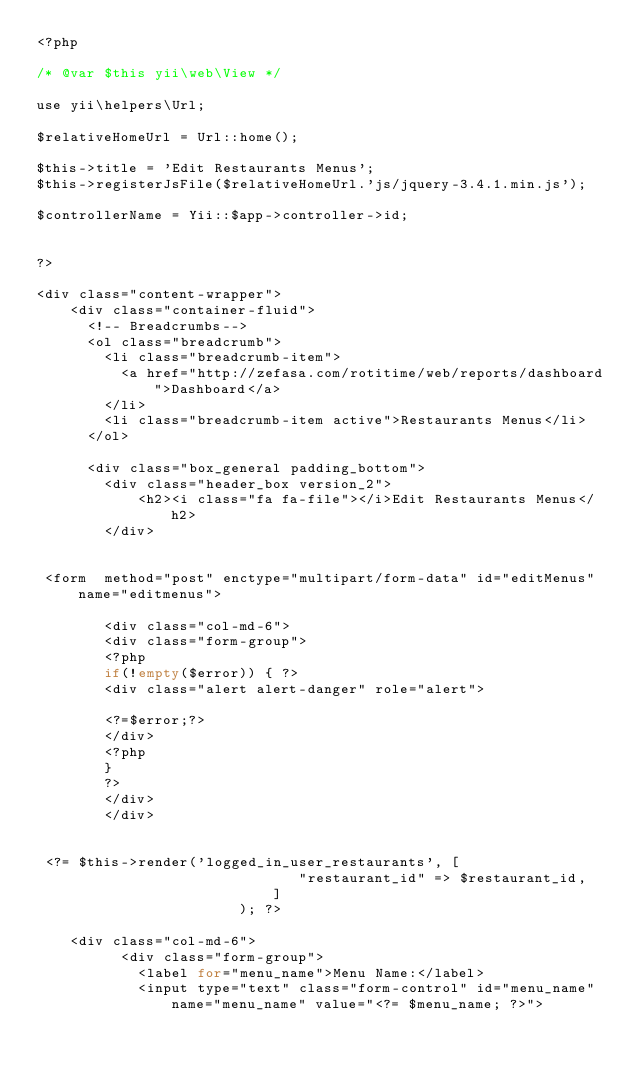Convert code to text. <code><loc_0><loc_0><loc_500><loc_500><_PHP_><?php

/* @var $this yii\web\View */

use yii\helpers\Url;

$relativeHomeUrl = Url::home();

$this->title = 'Edit Restaurants Menus';
$this->registerJsFile($relativeHomeUrl.'js/jquery-3.4.1.min.js');

$controllerName = Yii::$app->controller->id;


?>

<div class="content-wrapper">
    <div class="container-fluid">
      <!-- Breadcrumbs-->
      <ol class="breadcrumb">
        <li class="breadcrumb-item">
          <a href="http://zefasa.com/rotitime/web/reports/dashboard">Dashboard</a>
        </li>
        <li class="breadcrumb-item active">Restaurants Menus</li>
      </ol>

      <div class="box_general padding_bottom">
        <div class="header_box version_2">
            <h2><i class="fa fa-file"></i>Edit Restaurants Menus</h2>
        </div>
		
		
 <form  method="post" enctype="multipart/form-data" id="editMenus" name="editmenus">
 
        <div class="col-md-6">
		<div class="form-group">
		<?php
		if(!empty($error)) { ?>
		<div class="alert alert-danger" role="alert">

		<?=$error;?>
		</div>
		<?php
		}
		?>
		</div>
		</div>
 
 
 <?= $this->render('logged_in_user_restaurants', [
                               "restaurant_id" => $restaurant_id,
                            ]
                        ); ?>
 
    <div class="col-md-6">
		  <div class="form-group">
			<label for="menu_name">Menu Name:</label>
			<input type="text" class="form-control" id="menu_name" name="menu_name" value="<?= $menu_name; ?>"></code> 